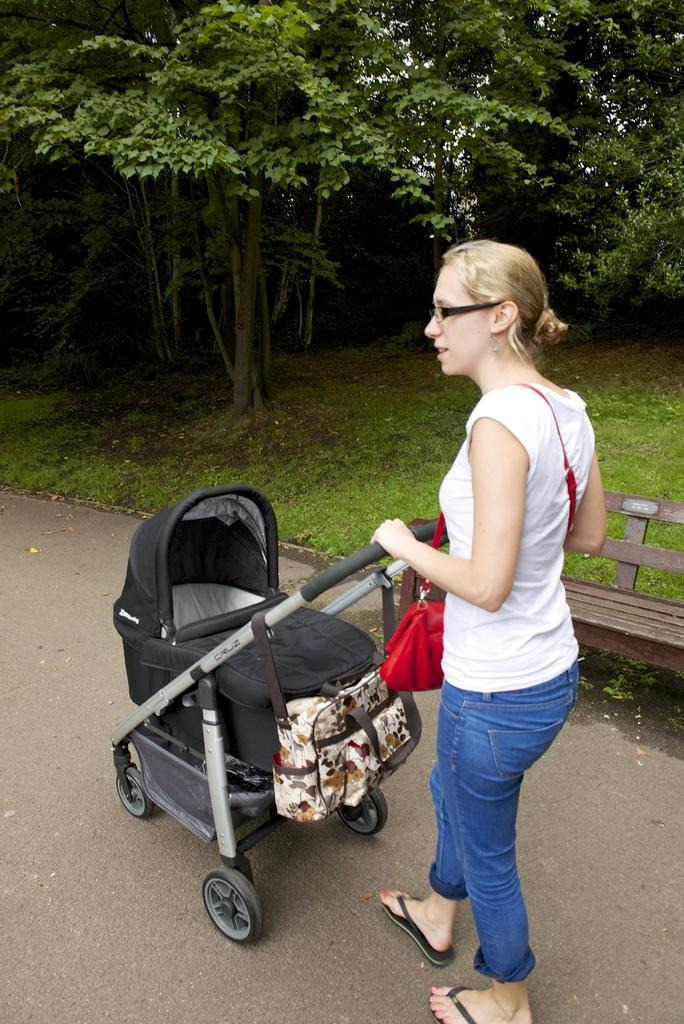What is the person in the image holding? The person is holding a baby trolley in the image. What type of surface can be seen in the image? The road is visible in the image. What is the ground like in the image? The ground has grass in the image. What type of vegetation is present in the image? There are trees in the image. Can you describe the unspecified object on the right side of the image? Unfortunately, the facts provided do not give enough information to describe the unspecified object on the right side of the image. What type of skate is the manager using to move around in the image? There is no manager or skate present in the image. What sound does the horn make in the image? There is no horn present in the image. 